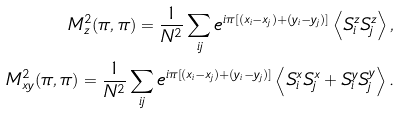<formula> <loc_0><loc_0><loc_500><loc_500>M ^ { 2 } _ { z } ( \pi , \pi ) = \frac { 1 } { N ^ { 2 } } \sum _ { i j } e ^ { i \pi [ ( x _ { i } - x _ { j } ) + ( y _ { i } - y _ { j } ) ] } \left \langle S _ { i } ^ { z } S _ { j } ^ { z } \right \rangle , \\ M ^ { 2 } _ { x y } ( \pi , \pi ) = \frac { 1 } { N ^ { 2 } } \sum _ { i j } e ^ { i \pi [ ( x _ { i } - x _ { j } ) + ( y _ { i } - y _ { j } ) ] } \left \langle S _ { i } ^ { x } S _ { j } ^ { x } + S _ { i } ^ { y } S _ { j } ^ { y } \right \rangle .</formula> 